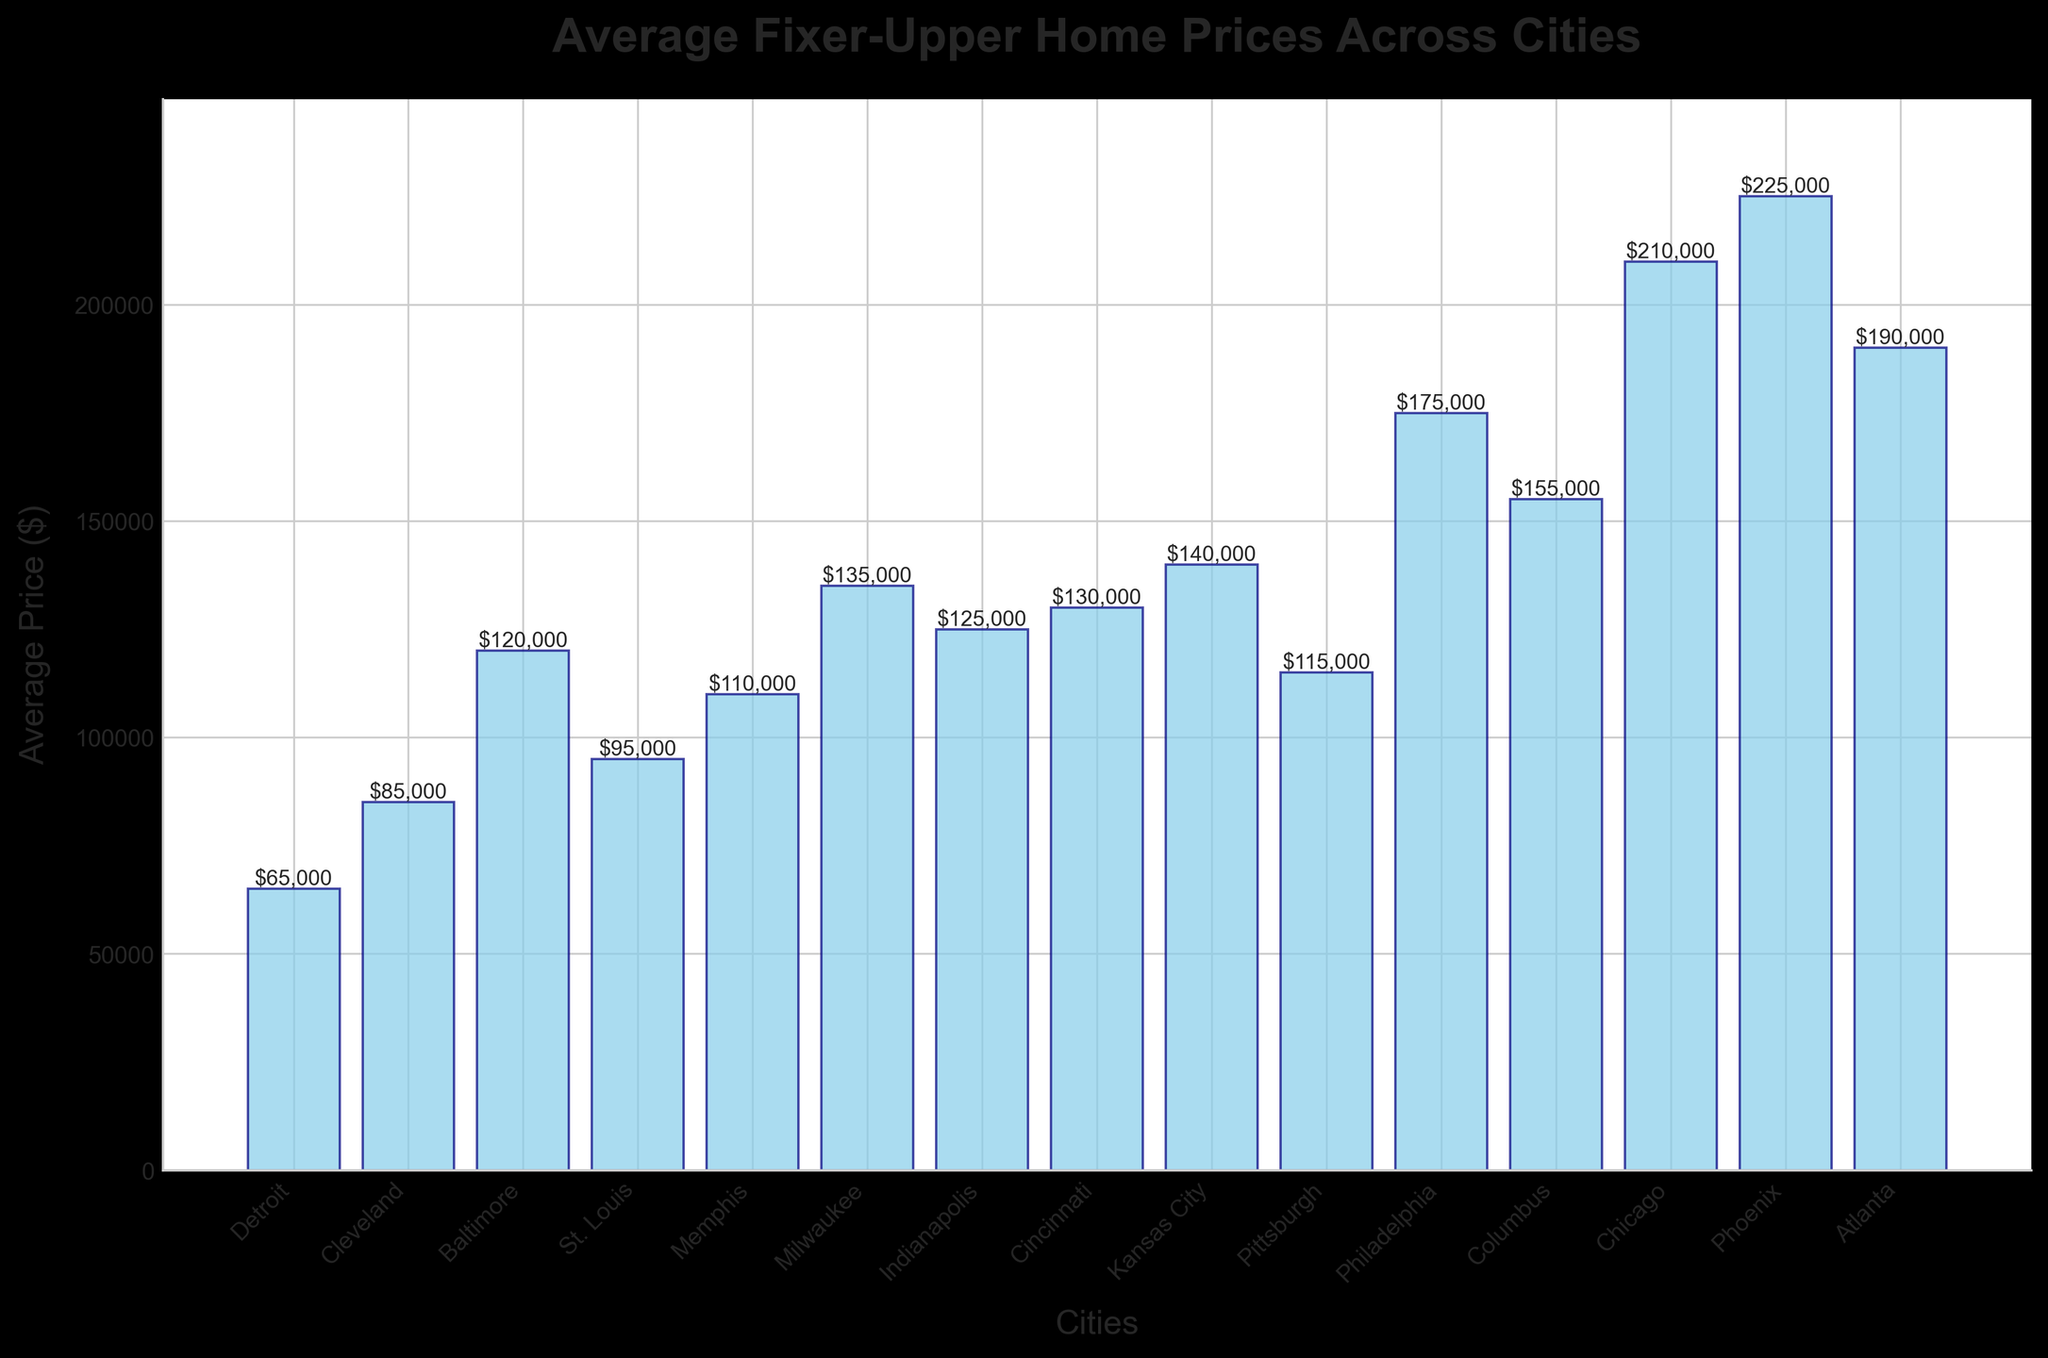Which city has the lowest average fixer-upper price? To answer this question, identify the city with the shortest bar in the chart with the label of the lowest price among the cities.
Answer: Detroit Which city has the highest average fixer-upper price? Find the city with the tallest bar in the chart, indicating the highest price among the cities.
Answer: Phoenix How much higher is the average fixer-upper price in Chicago compared to Detroit? Locate the bars for Chicago and Detroit and subtract the price of Detroit ($65,000) from the price of Chicago ($210,000). The difference is $210,000 - $65,000.
Answer: $145,000 Which cities have an average fixer-upper price of over $200,000? Identify the cities whose bars exceed the $200,000 line. The prices of the cities should be higher than $200,000.
Answer: Chicago, Phoenix What is the total average fixer-upper price for the cities of Milwaukee and Indianapolis? Locate the bars for Milwaukee and Indianapolis. Add their prices as follows: $135,000 (Milwaukee) + $125,000 (Indianapolis).
Answer: $260,000 Which city in the dataset has an average fixer-upper price closest to $150,000? Find the bar that is closest to the $150,000 line but does not necessarily have to match it exactly.
Answer: Columbus List all the cities with average fixer-upper prices between $100,000 and $150,000. Identify and list all cities whose bar heights fall in the range between $100,000 and $150,000.
Answer: Baltimore, St. Louis, Memphis, Milwaukee, Indianapolis, Cincinnati, Pittsburgh How much does the average price in Atlanta differ from that in Philadelphia? Locate the bars for Atlanta and Philadelphia. Subtract the price of Philadelphia ($175,000) from the price of Atlanta ($190,000). The difference is $190,000 - $175,000.
Answer: $15,000 Which city has a higher average price, Cleveland or Memphis? Compare the heights of the bars for Cleveland and Memphis. Identify which bar is taller, indicating a higher average price.
Answer: Memphis Calculate the difference in average fixer-upper price between Kansas City and St. Louis. Find the bars for Kansas City and St. Louis. Subtract the price of St. Louis ($95,000) from the price of Kansas City ($140,000). The difference is $140,000 - $95,000.
Answer: $45,000 